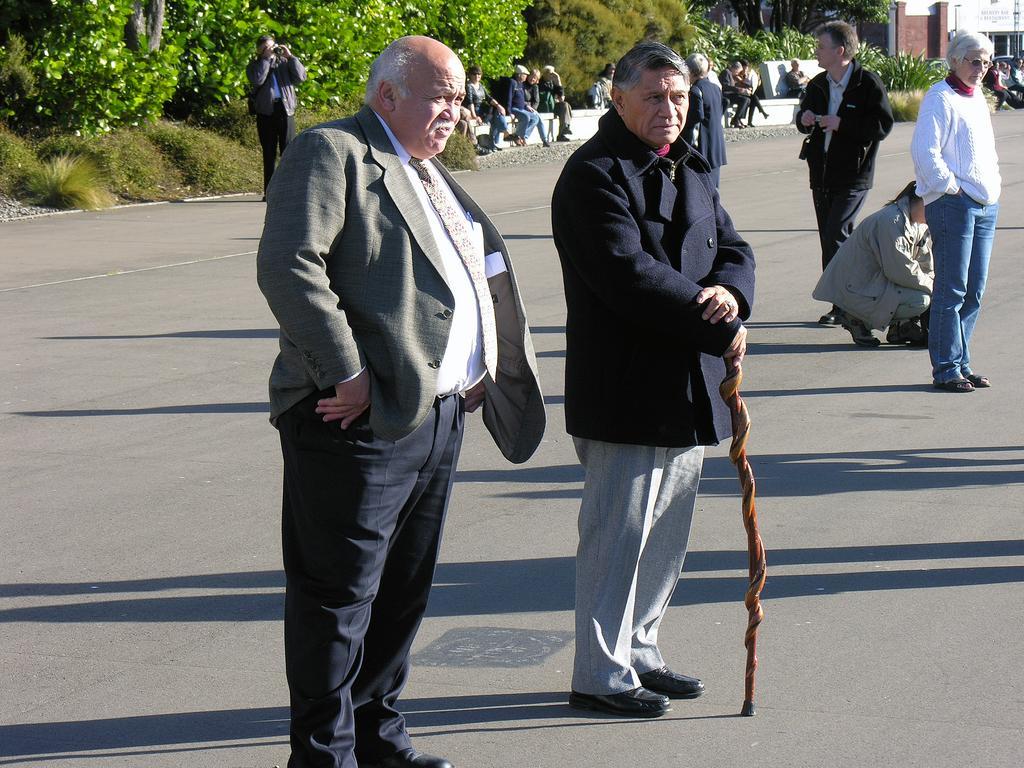Could you give a brief overview of what you see in this image? In this image, we can see there are persons on the road. One of them is holding a stick. In the background, there are persons sitting, there are trees, plants and a building. 